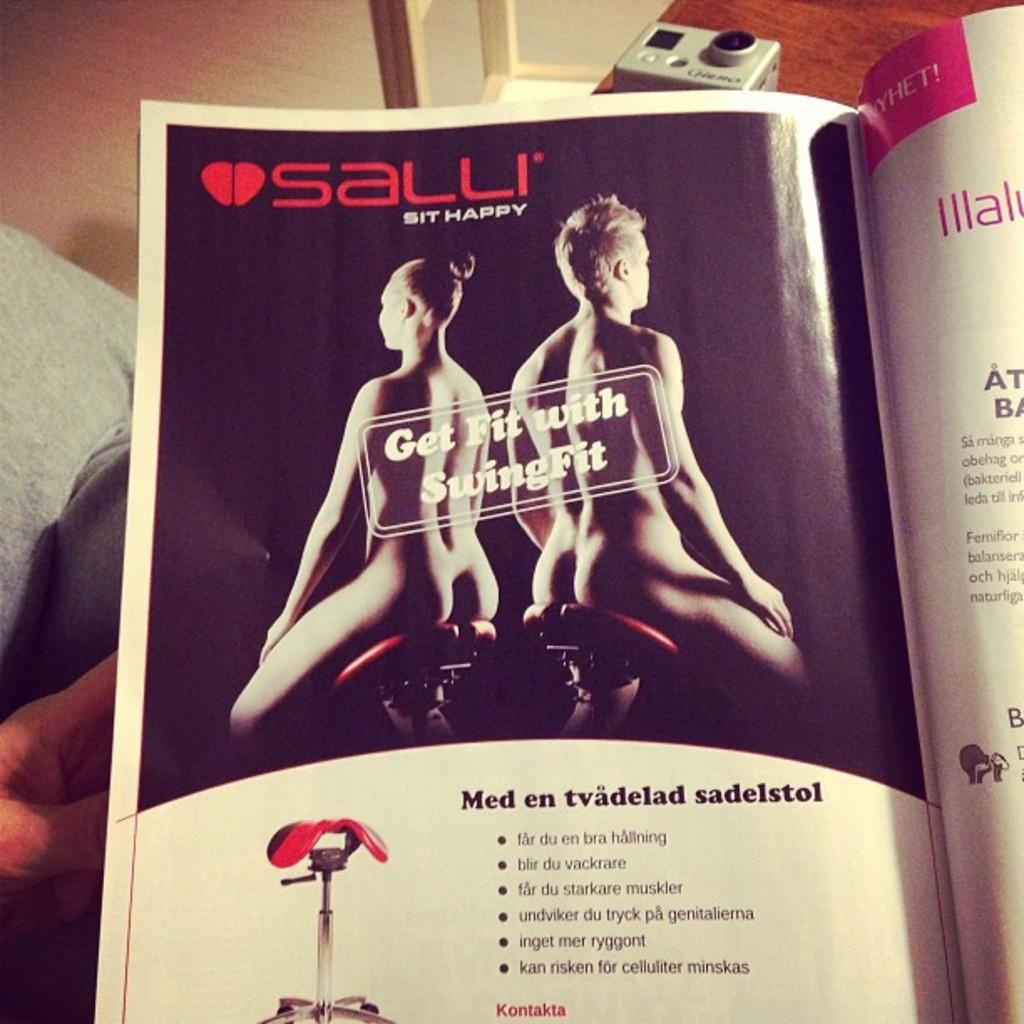How many people are sitting in the image? There are two persons sitting in the image. What are the persons doing in the image? The provided facts do not specify what the persons are doing. What can be seen inside the book in the image? There are objects visible in a book in the image. What is the color of the object on the table in the image? The object on the table is ash-colored. What type of yak can be seen in the image? There is no yak present in the image. How many sisters are visible in the image? The provided facts do not mention any sisters in the image. 